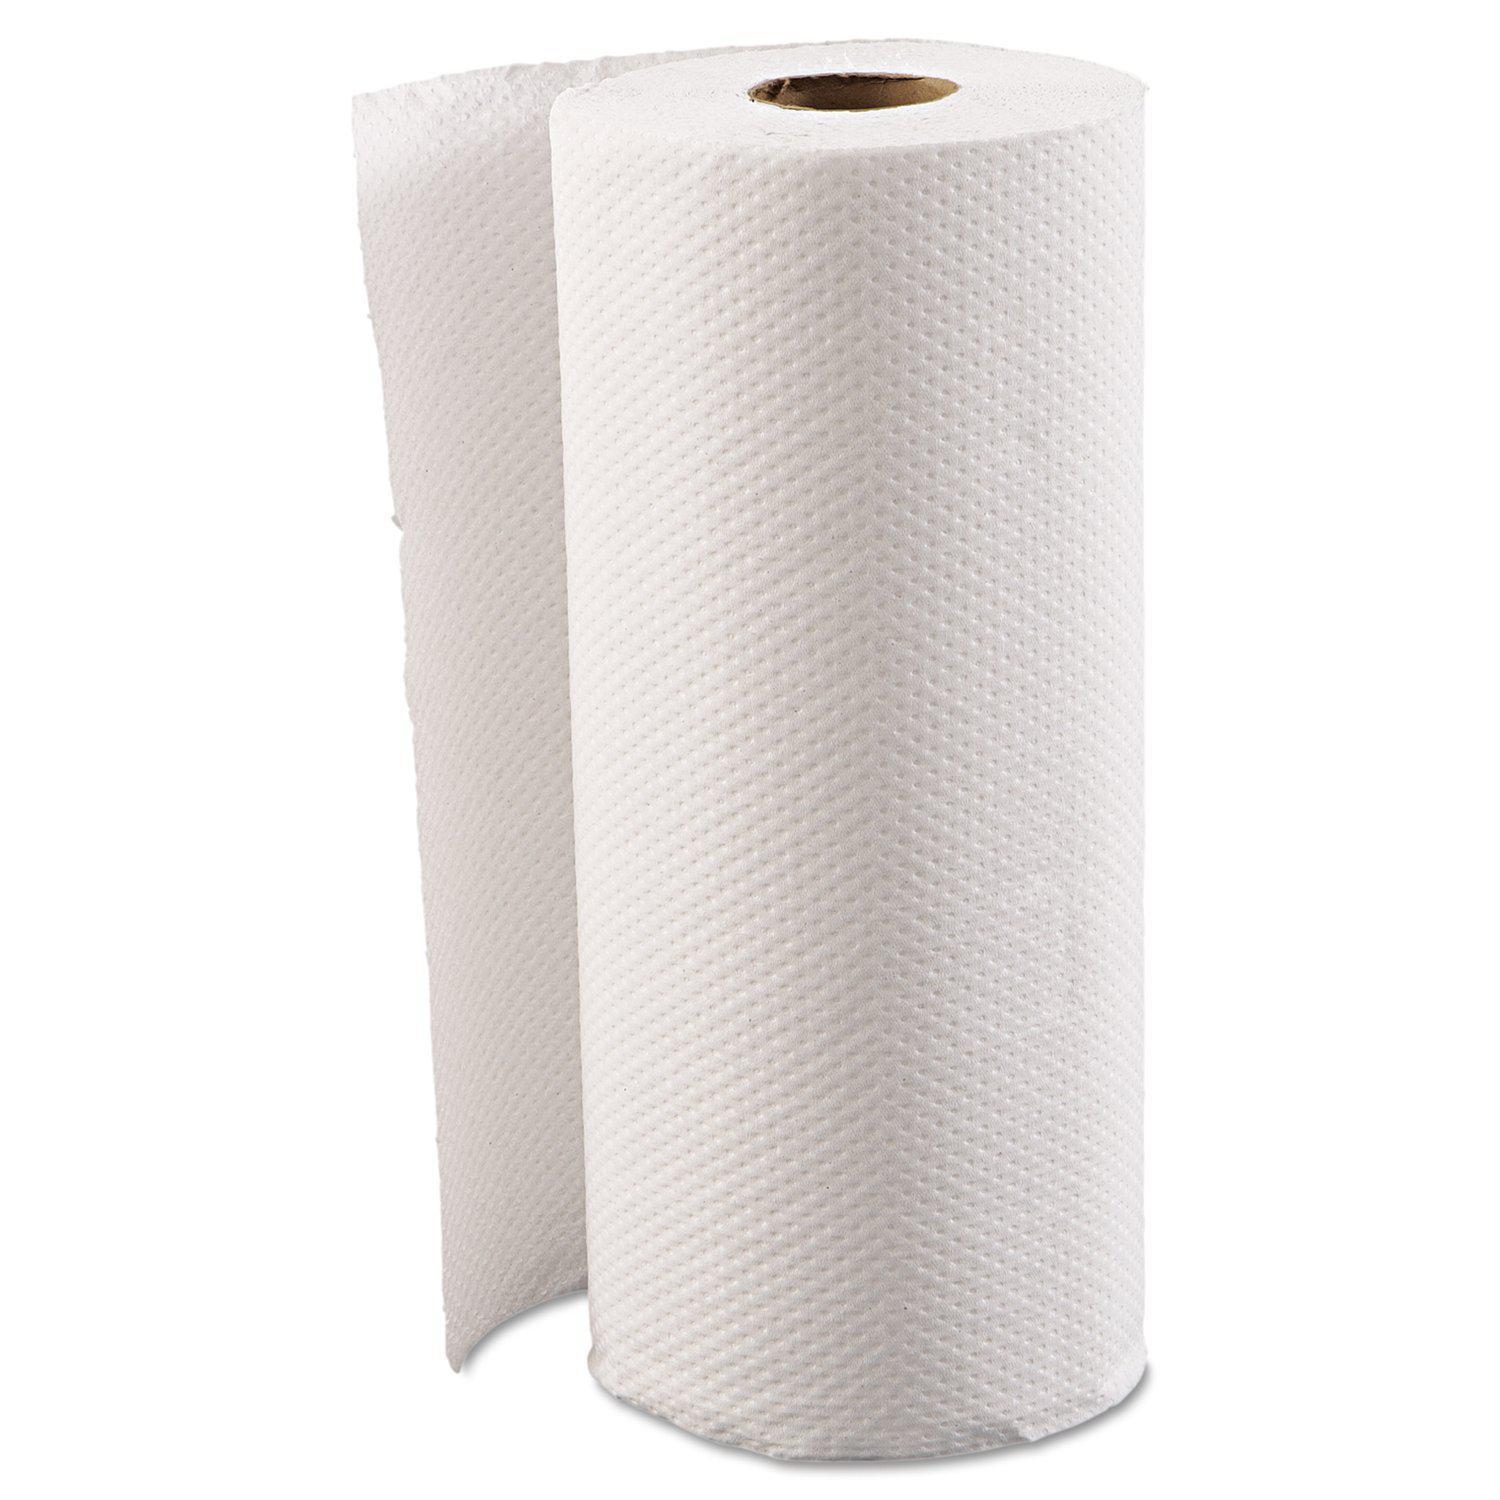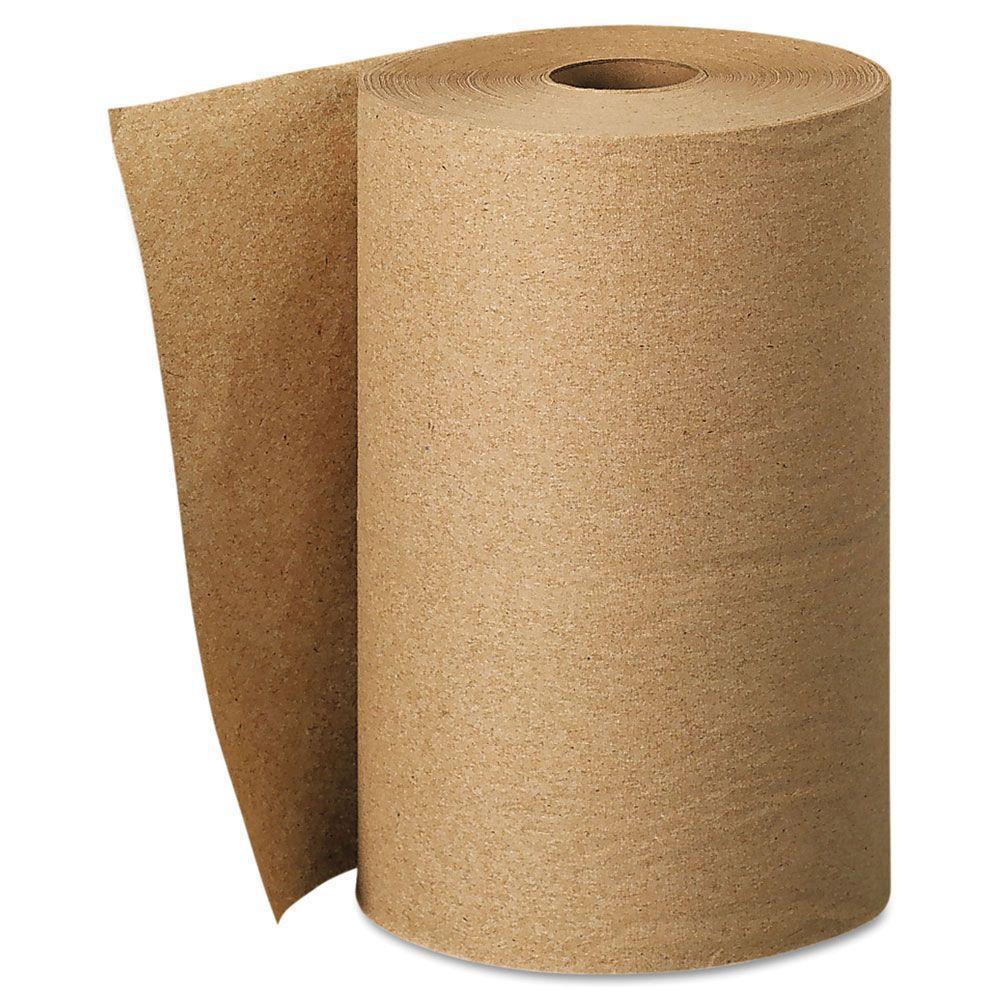The first image is the image on the left, the second image is the image on the right. For the images displayed, is the sentence "An image contains a roll of brown paper towels." factually correct? Answer yes or no. Yes. The first image is the image on the left, the second image is the image on the right. Examine the images to the left and right. Is the description "An image shows one upright roll of paper towels the color of brown craft paper." accurate? Answer yes or no. Yes. 